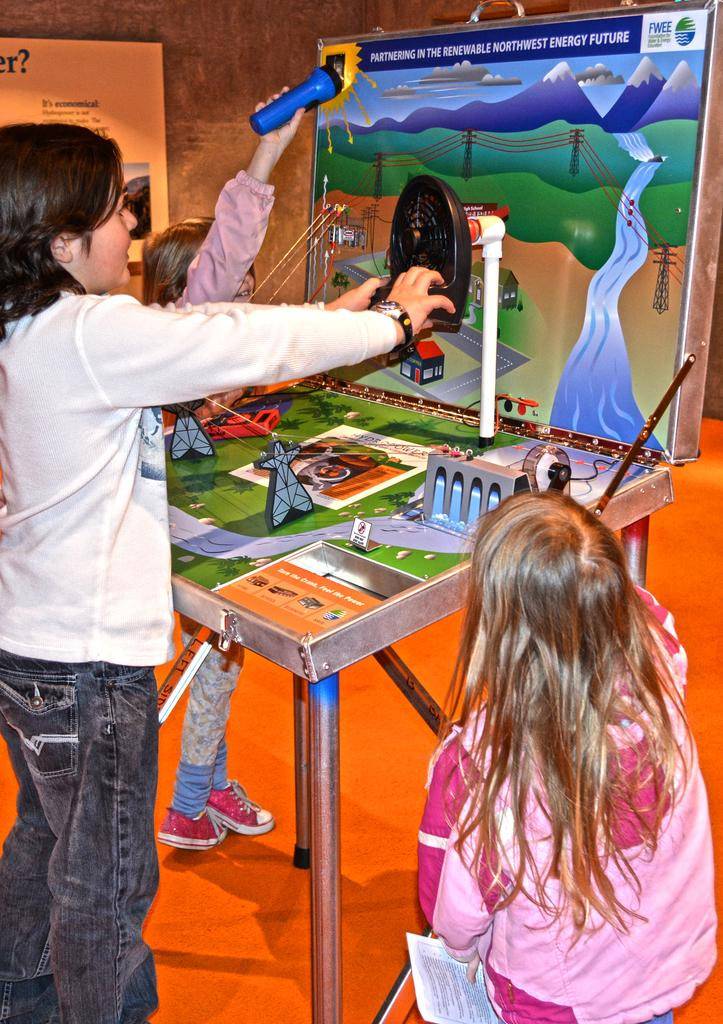How many people are in the image? There are three persons in the image. What are the persons doing in the image? They are playing a game. Can you describe the surface they are standing on? They are standing on the floor. What else can be seen in the image besides the people? There is a table in the image, and there is a frame on the wall in the background. Is the floor visible in the image? Yes, the floor is visible in the image. What type of grip can be seen on the frame in the image? There is no grip visible on the frame in the image; it is a decorative element on the wall. 